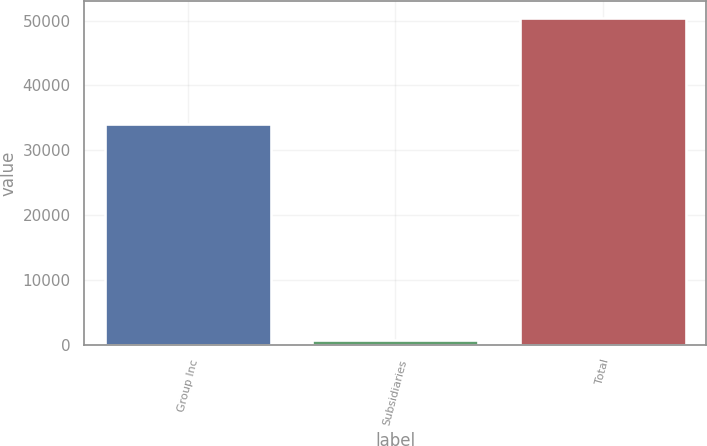<chart> <loc_0><loc_0><loc_500><loc_500><bar_chart><fcel>Group Inc<fcel>Subsidiaries<fcel>Total<nl><fcel>34070<fcel>710<fcel>50452<nl></chart> 